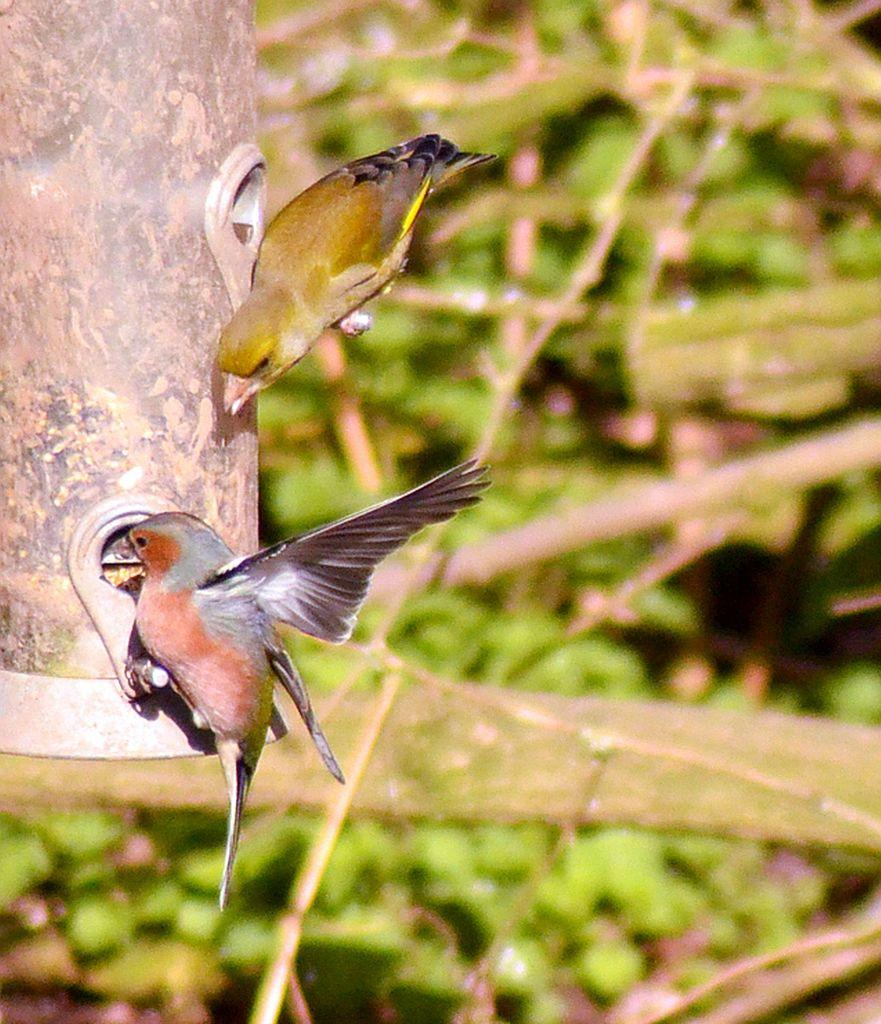Where is the bird nest located in the image? The bird nest is in the top left side of the image. How many birds can be seen in the image? There are two birds in the image. What can be seen in the background of the image? Trees are visible in the background of the image. How would you describe the background of the image? The background of the image is blurred. Is there a camp visible in the image? No, there is no camp present in the image. What type of flag is being flown by the birds in the image? There are no flags present in the image; it features a bird nest and two birds. 